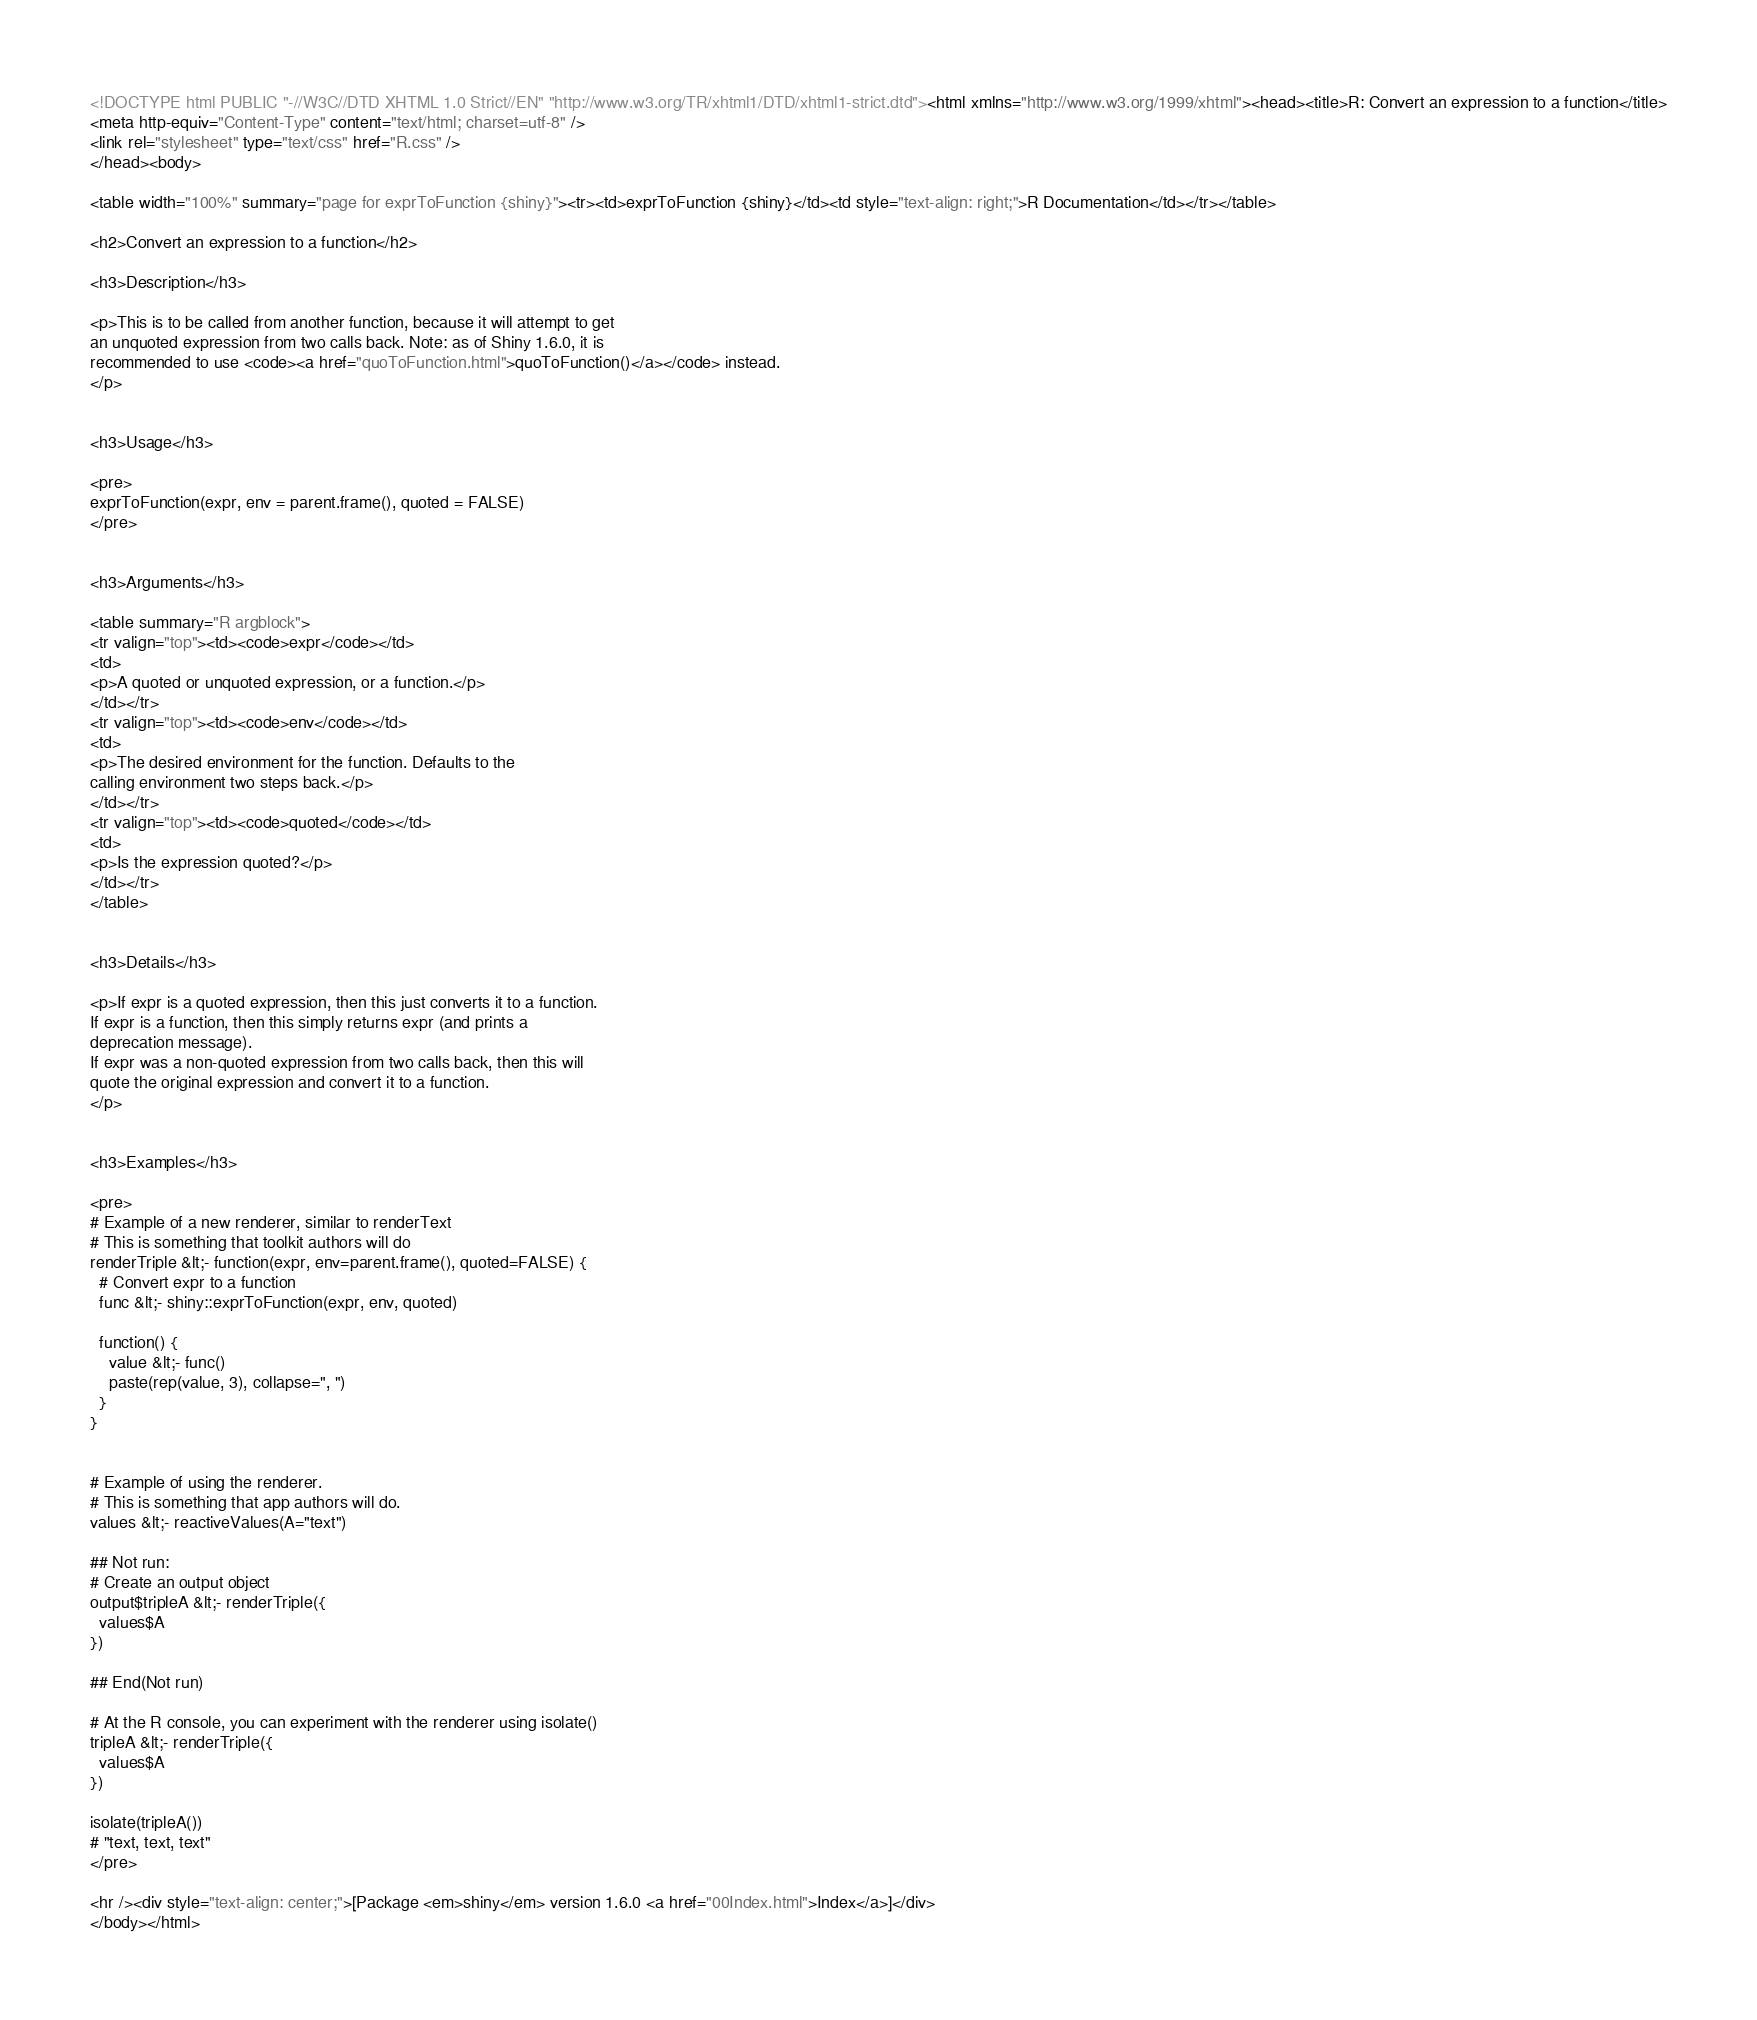Convert code to text. <code><loc_0><loc_0><loc_500><loc_500><_HTML_><!DOCTYPE html PUBLIC "-//W3C//DTD XHTML 1.0 Strict//EN" "http://www.w3.org/TR/xhtml1/DTD/xhtml1-strict.dtd"><html xmlns="http://www.w3.org/1999/xhtml"><head><title>R: Convert an expression to a function</title>
<meta http-equiv="Content-Type" content="text/html; charset=utf-8" />
<link rel="stylesheet" type="text/css" href="R.css" />
</head><body>

<table width="100%" summary="page for exprToFunction {shiny}"><tr><td>exprToFunction {shiny}</td><td style="text-align: right;">R Documentation</td></tr></table>

<h2>Convert an expression to a function</h2>

<h3>Description</h3>

<p>This is to be called from another function, because it will attempt to get
an unquoted expression from two calls back. Note: as of Shiny 1.6.0, it is
recommended to use <code><a href="quoToFunction.html">quoToFunction()</a></code> instead.
</p>


<h3>Usage</h3>

<pre>
exprToFunction(expr, env = parent.frame(), quoted = FALSE)
</pre>


<h3>Arguments</h3>

<table summary="R argblock">
<tr valign="top"><td><code>expr</code></td>
<td>
<p>A quoted or unquoted expression, or a function.</p>
</td></tr>
<tr valign="top"><td><code>env</code></td>
<td>
<p>The desired environment for the function. Defaults to the
calling environment two steps back.</p>
</td></tr>
<tr valign="top"><td><code>quoted</code></td>
<td>
<p>Is the expression quoted?</p>
</td></tr>
</table>


<h3>Details</h3>

<p>If expr is a quoted expression, then this just converts it to a function.
If expr is a function, then this simply returns expr (and prints a
deprecation message).
If expr was a non-quoted expression from two calls back, then this will
quote the original expression and convert it to a function.
</p>


<h3>Examples</h3>

<pre>
# Example of a new renderer, similar to renderText
# This is something that toolkit authors will do
renderTriple &lt;- function(expr, env=parent.frame(), quoted=FALSE) {
  # Convert expr to a function
  func &lt;- shiny::exprToFunction(expr, env, quoted)

  function() {
    value &lt;- func()
    paste(rep(value, 3), collapse=", ")
  }
}


# Example of using the renderer.
# This is something that app authors will do.
values &lt;- reactiveValues(A="text")

## Not run: 
# Create an output object
output$tripleA &lt;- renderTriple({
  values$A
})

## End(Not run)

# At the R console, you can experiment with the renderer using isolate()
tripleA &lt;- renderTriple({
  values$A
})

isolate(tripleA())
# "text, text, text"
</pre>

<hr /><div style="text-align: center;">[Package <em>shiny</em> version 1.6.0 <a href="00Index.html">Index</a>]</div>
</body></html>
</code> 